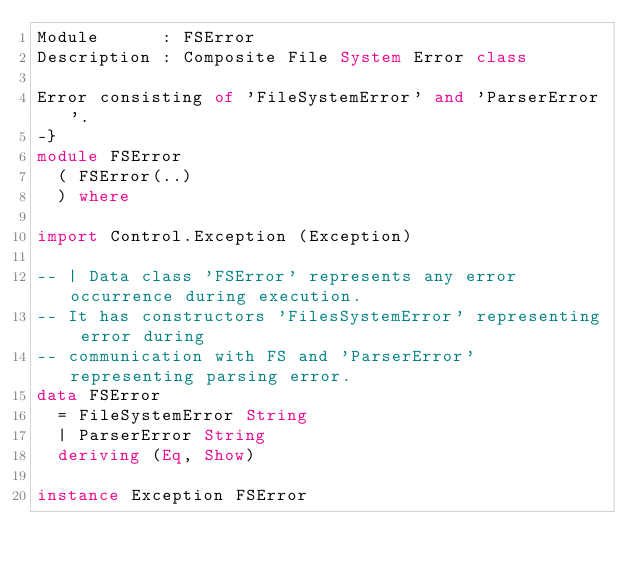Convert code to text. <code><loc_0><loc_0><loc_500><loc_500><_Haskell_>Module      : FSError
Description : Composite File System Error class
  
Error consisting of 'FileSystemError' and 'ParserError'.
-}
module FSError
  ( FSError(..)
  ) where

import Control.Exception (Exception)

-- | Data class 'FSError' represents any error occurrence during execution.
-- It has constructors 'FilesSystemError' representing error during 
-- communication with FS and 'ParserError' representing parsing error. 
data FSError
  = FileSystemError String
  | ParserError String
  deriving (Eq, Show)

instance Exception FSError</code> 